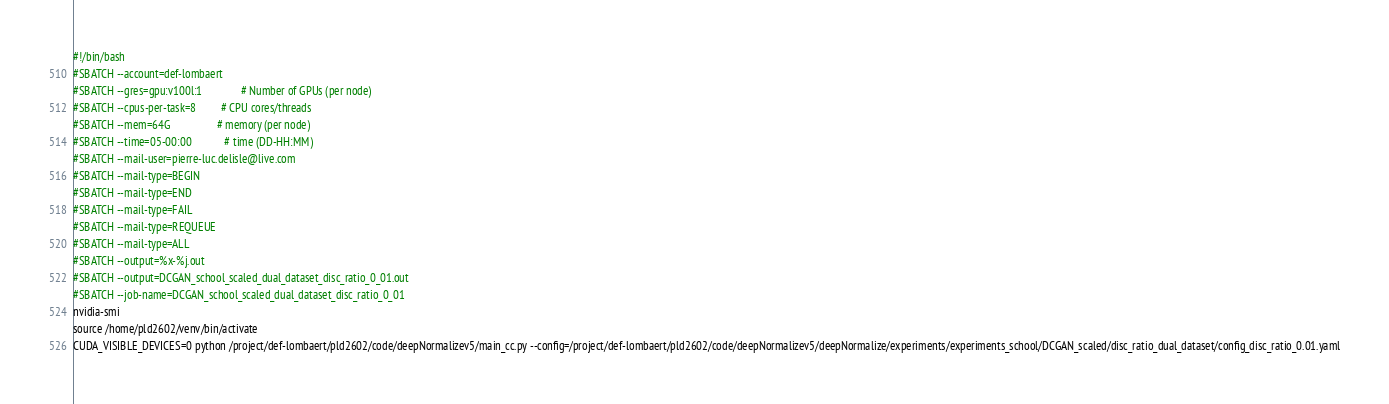<code> <loc_0><loc_0><loc_500><loc_500><_Bash_>#!/bin/bash
#SBATCH --account=def-lombaert
#SBATCH --gres=gpu:v100l:1              # Number of GPUs (per node)
#SBATCH --cpus-per-task=8         # CPU cores/threads
#SBATCH --mem=64G                 # memory (per node)
#SBATCH --time=05-00:00            # time (DD-HH:MM)
#SBATCH --mail-user=pierre-luc.delisle@live.com
#SBATCH --mail-type=BEGIN
#SBATCH --mail-type=END
#SBATCH --mail-type=FAIL
#SBATCH --mail-type=REQUEUE
#SBATCH --mail-type=ALL
#SBATCH --output=%x-%j.out
#SBATCH --output=DCGAN_school_scaled_dual_dataset_disc_ratio_0_01.out
#SBATCH --job-name=DCGAN_school_scaled_dual_dataset_disc_ratio_0_01
nvidia-smi
source /home/pld2602/venv/bin/activate
CUDA_VISIBLE_DEVICES=0 python /project/def-lombaert/pld2602/code/deepNormalizev5/main_cc.py --config=/project/def-lombaert/pld2602/code/deepNormalizev5/deepNormalize/experiments/experiments_school/DCGAN_scaled/disc_ratio_dual_dataset/config_disc_ratio_0.01.yaml</code> 